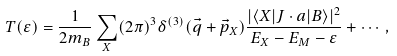Convert formula to latex. <formula><loc_0><loc_0><loc_500><loc_500>T ( \varepsilon ) = \frac { 1 } { 2 m _ { B } } \sum _ { X } ( 2 \pi ) ^ { 3 } \delta ^ { ( 3 ) } ( \vec { q } + \vec { p } _ { X } ) \frac { | \langle X | J \cdot a | B \rangle | ^ { 2 } } { E _ { X } - E _ { M } - \varepsilon } + \cdots ,</formula> 